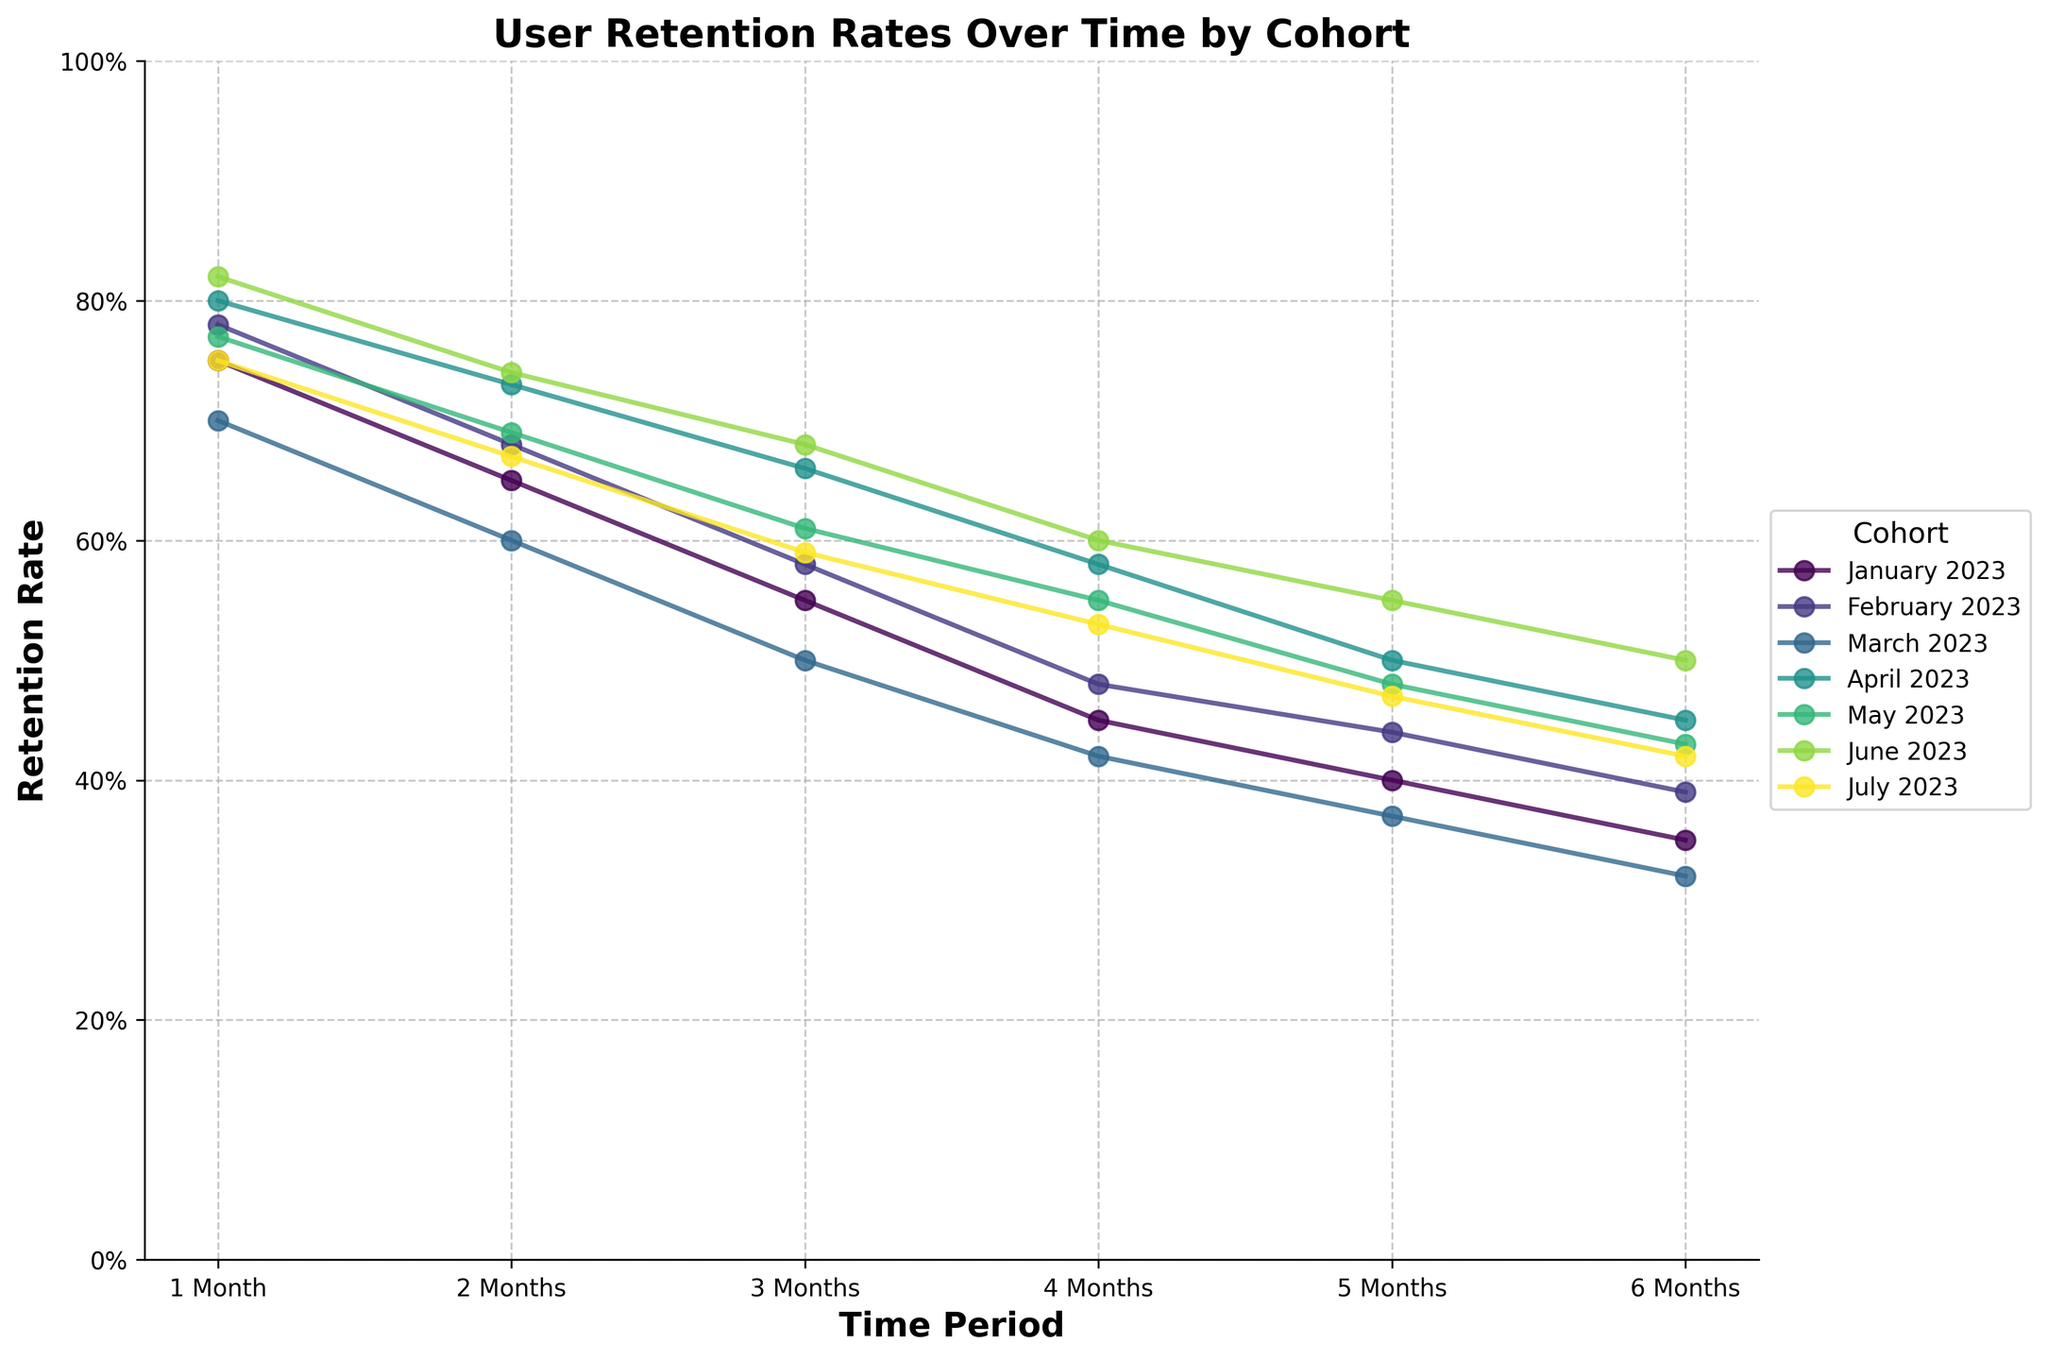What is the title of the figure? The title of the figure is located at the top center. One can simply read the title directly from the figure.
Answer: User Retention Rates Over Time by Cohort Which cohort has the highest retention rate in the 1st month? To find the highest retention rate in the 1st month, identify the rates for each cohort at the 1 month mark and compare them.
Answer: June 2023 What is the retention rate of the March 2023 cohort at the 4th month? Locate the line for the March 2023 cohort on the plot and find the retention rate corresponding to the 4th month on the x-axis.
Answer: 42% Which cohort shows the steepest decline in retention rate from the 1st month to the 6th month? To determine the steepest decline, find the difference in retention rate from the 1st to the 6th month for each cohort and identify the largest drop.
Answer: June 2023 What is the retention rate difference between the February 2023 and March 2023 cohorts at the 3rd month? Locate the retention rates for both cohorts at the 3rd month on the plot and calculate the difference by subtracting the value for March 2023 from February 2023.
Answer: 8% Which cohort maintains the highest retention rate at the 3rd month? Check the retention rates at the 3rd month for each cohort and determine which one is the highest.
Answer: June 2023 How does the retention rate of the April 2023 cohort change from the 1st month to the 6th month? Locate the April 2023 line and follow it from the 1st to the 6th month, noting the retention rates at each month to observe the change.
Answer: Drops from 80% to 45% Is there any cohort that has a higher retention rate in the 6th month than the retention rate of the March 2023 cohort in the 5th month? Compare the retention rates in the 6th month of each cohort with the 5th month retention rate of March 2023, which is 37%.
Answer: Yes, the June 2023 cohort with 50% Which month-to-month period shows the most significant retention rate drop for the May 2023 cohort? Identify the retention rates for the May 2023 cohort at each month and calculate the differences between consecutive months to find the largest drop.
Answer: 2nd to 3rd month 